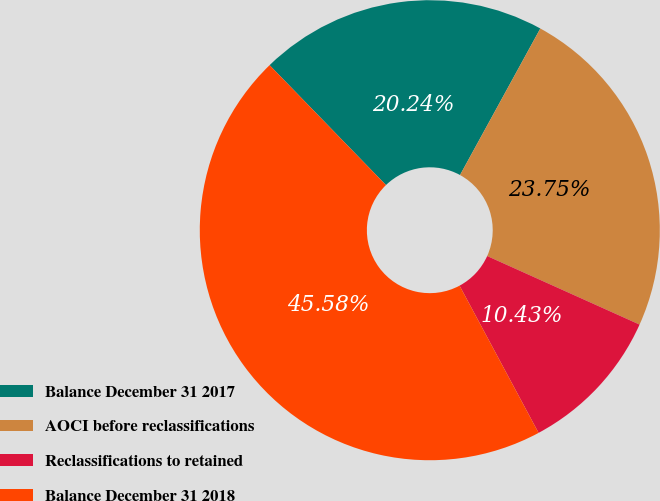<chart> <loc_0><loc_0><loc_500><loc_500><pie_chart><fcel>Balance December 31 2017<fcel>AOCI before reclassifications<fcel>Reclassifications to retained<fcel>Balance December 31 2018<nl><fcel>20.24%<fcel>23.75%<fcel>10.43%<fcel>45.58%<nl></chart> 